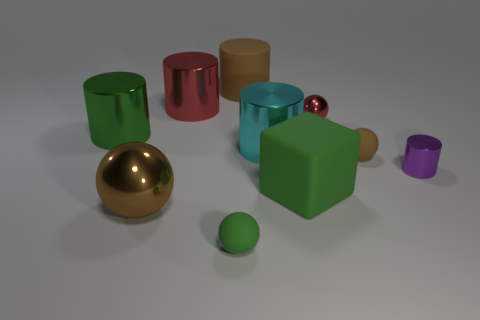In terms of design, why might someone choose to include objects with different finishes in one composition? In terms of design, including objects with different finishes such as matte, glossy, and metallic, can add visual interest and depth to a composition. It creates a contrast in textures that can highlight the individuality of each item, guide the viewer's eye through the scene, and even evoke different emotional responses based on the perceived 'feel' of the surfaces. 